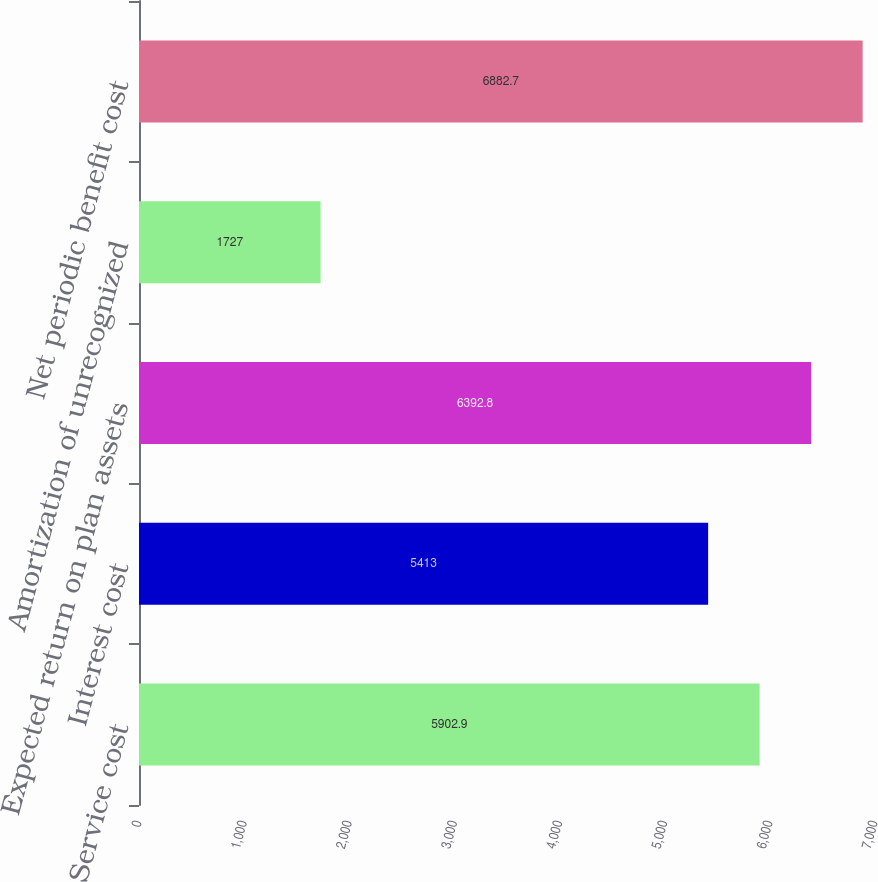<chart> <loc_0><loc_0><loc_500><loc_500><bar_chart><fcel>Service cost<fcel>Interest cost<fcel>Expected return on plan assets<fcel>Amortization of unrecognized<fcel>Net periodic benefit cost<nl><fcel>5902.9<fcel>5413<fcel>6392.8<fcel>1727<fcel>6882.7<nl></chart> 